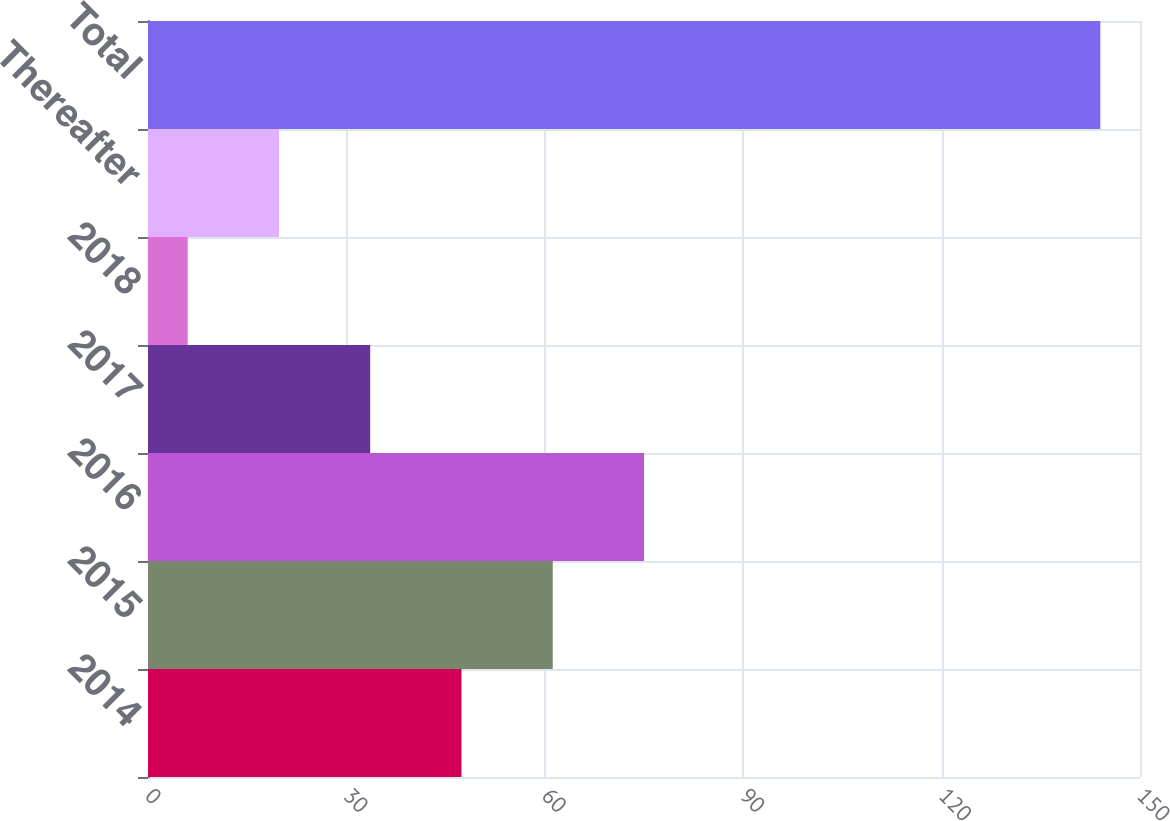Convert chart to OTSL. <chart><loc_0><loc_0><loc_500><loc_500><bar_chart><fcel>2014<fcel>2015<fcel>2016<fcel>2017<fcel>2018<fcel>Thereafter<fcel>Total<nl><fcel>47.4<fcel>61.2<fcel>75<fcel>33.6<fcel>6<fcel>19.8<fcel>144<nl></chart> 